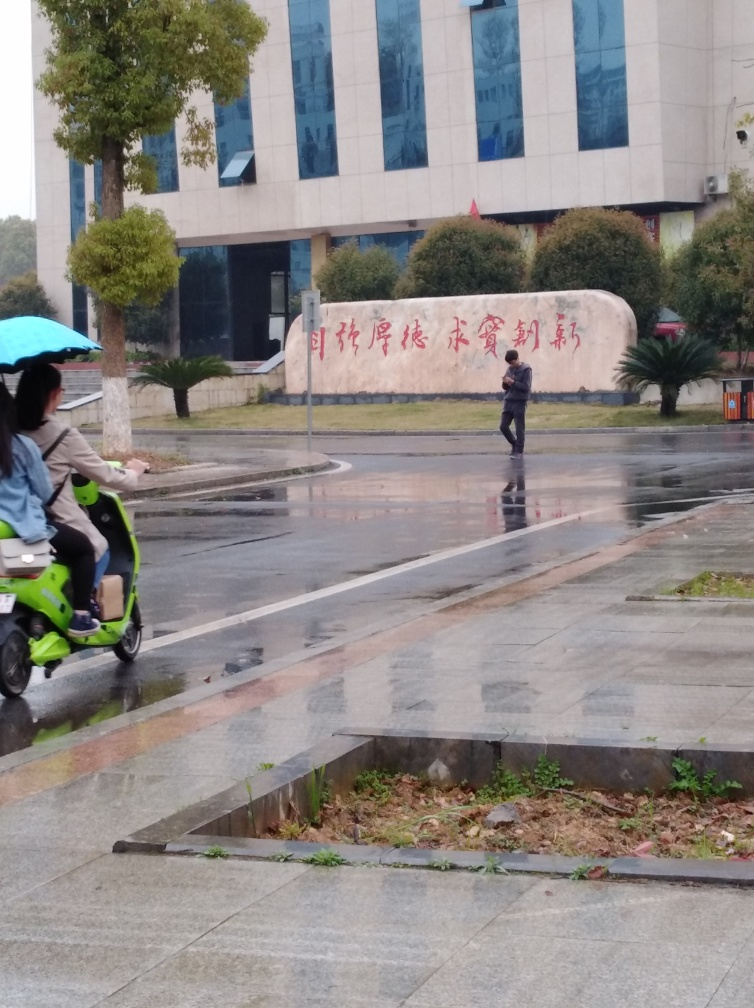Can you comment on the urban features visible in the image? The urban setting is characterized by modern features such as the reflective glass facade of the building, wide streets, and structured landscaping. There is a large wall with prominent text that suggests this site may have cultural or institutional significance. The mix of traditional elements, like the wall inscription, with the modern building indicates a blending of old and new styles typically found in many urban environments. 